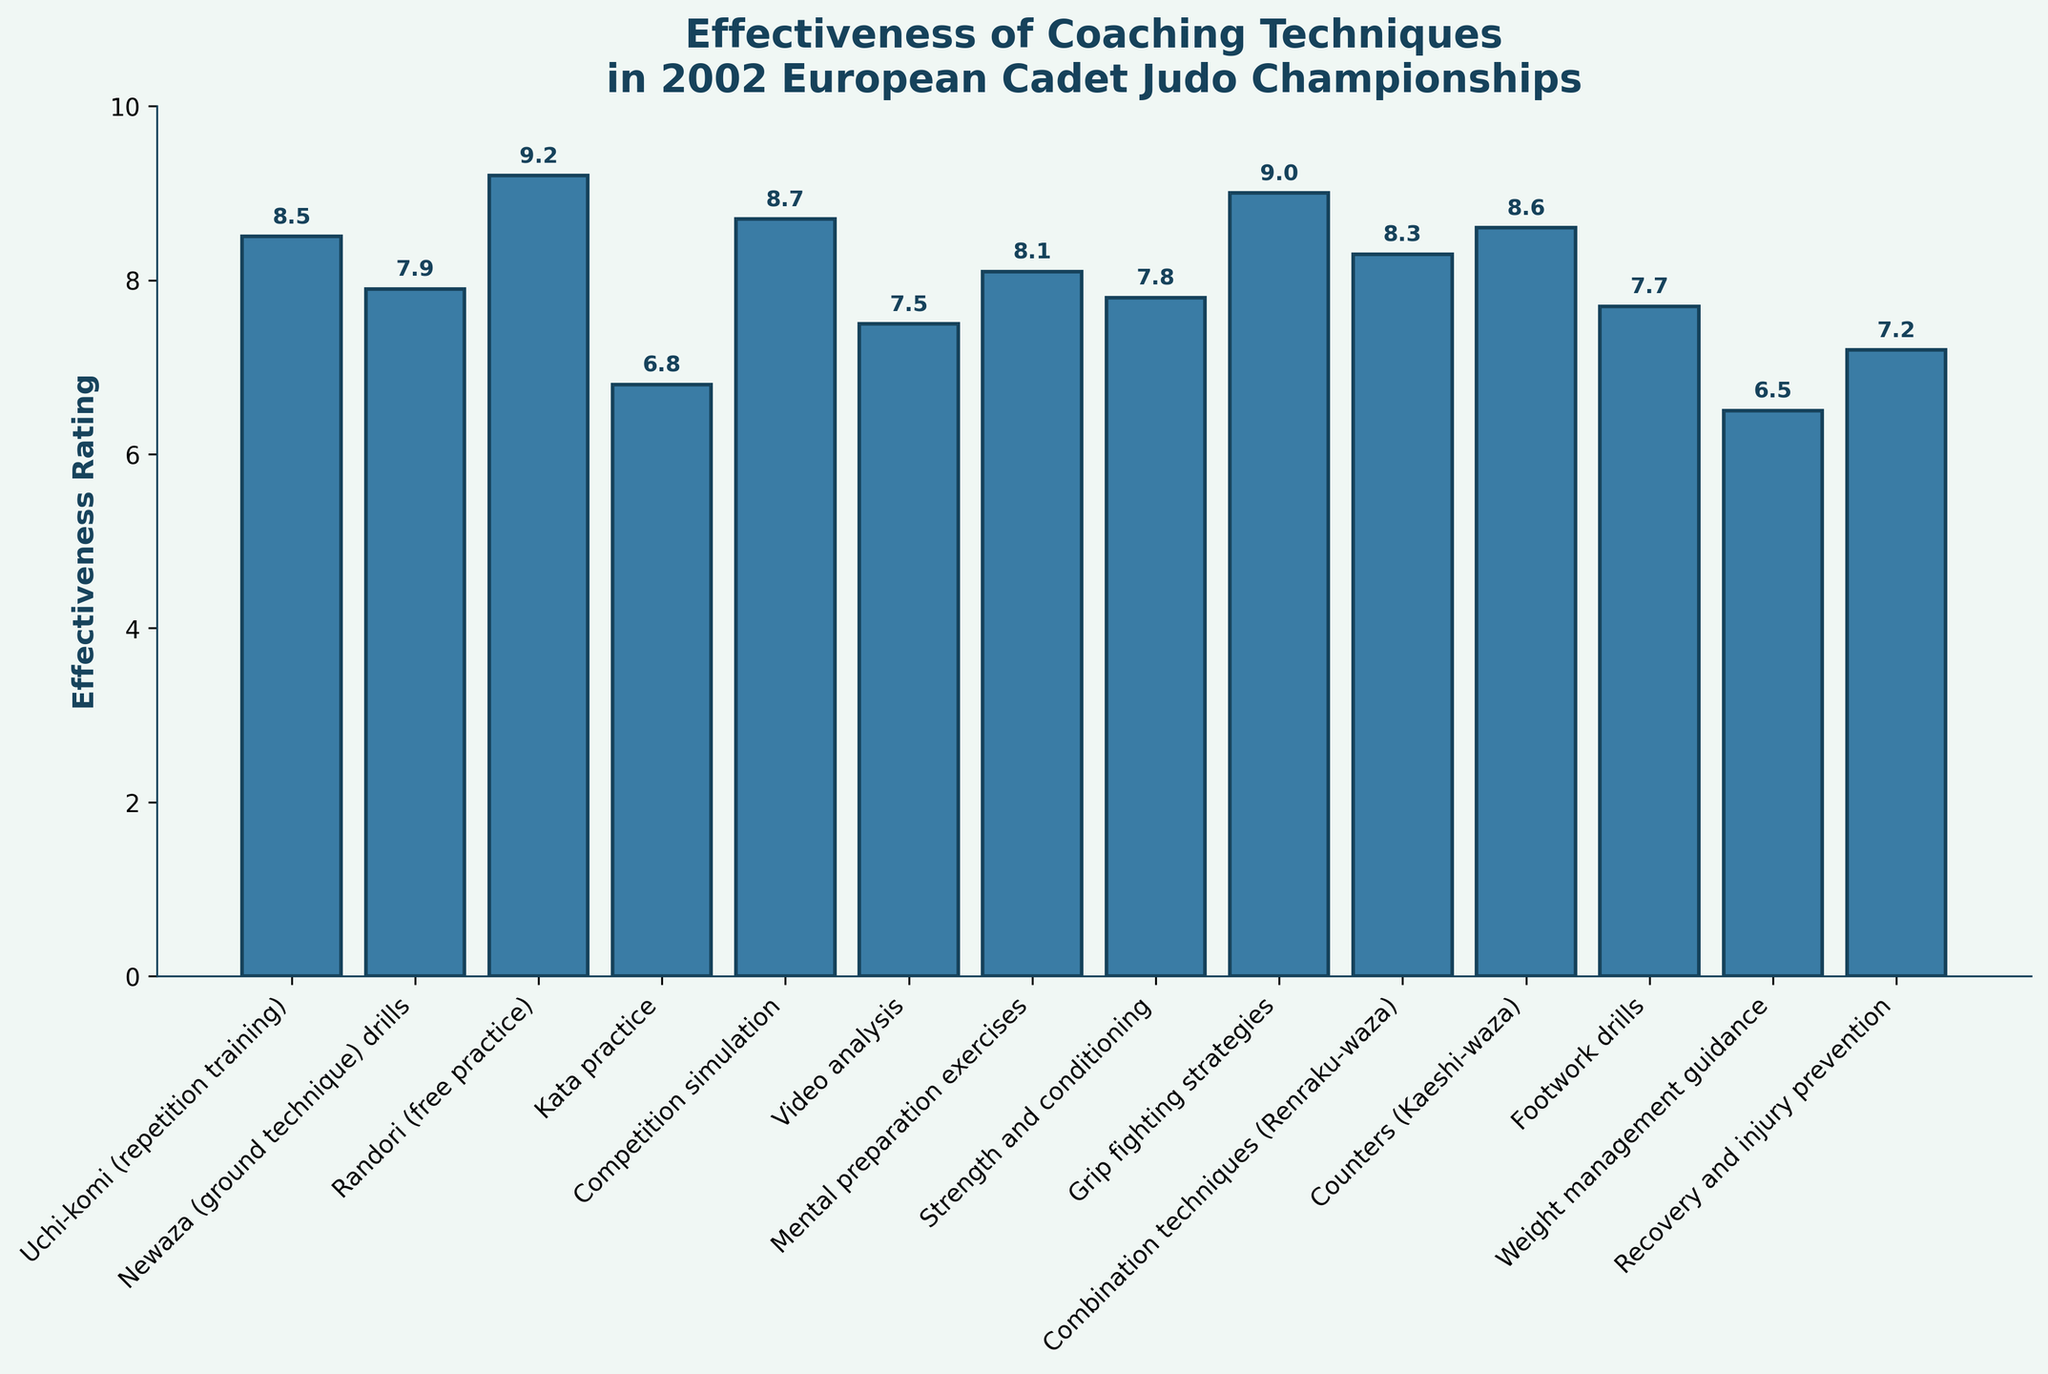What's the highest effectiveness rating among the coaching techniques? Look at the bar heights and the corresponding effectiveness ratings. The highest bar represents the highest rating.
Answer: 9.2 Which coaching technique received the lowest effectiveness rating? Check the base of all bars to see which one has the smallest value. The technique corresponding to that bar is the one with the lowest rating.
Answer: Weight management guidance How many coaching techniques have an effectiveness rating greater than 8? Identify all bars with a height above the 8-rating mark. Count these bars to get the total number.
Answer: 7 Which two techniques have effectiveness ratings closest to each other? Compare the values on top of each bar and find the two bars that have the smallest difference in their effectiveness ratings.
Answer: Strength and conditioning, Footwork drills What is the average effectiveness rating of techniques related to groundwork (Newaza drills, Recovery and injury prevention)? Sum the effectiveness ratings of Newaza drills and Recovery and injury prevention, then divide by 2. Calculation: (7.9 + 7.2) / 2 = 7.55.
Answer: 7.55 